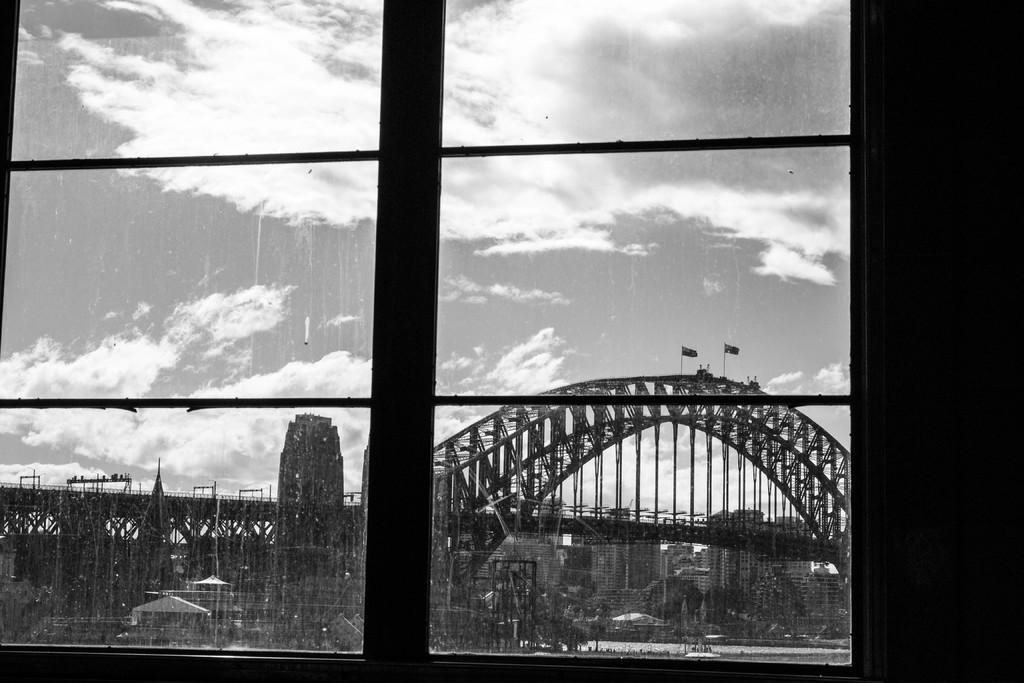What is located in the center of the image? There is a window in the center of the image. What can be seen through the window? Trees, bridges, and flags can be seen through the window. Reasoning: Let's think step by identifying the main subject in the image, which is the window. Then, we expand the conversation to include what can be seen through the window, which are trees, bridges, and flags. Each question is designed to elicit a specific detail about the image that is known from the provided facts. Absurd Question/Answer: What type of book is being read by the kitten in the image? There is no kitten or book present in the image. 